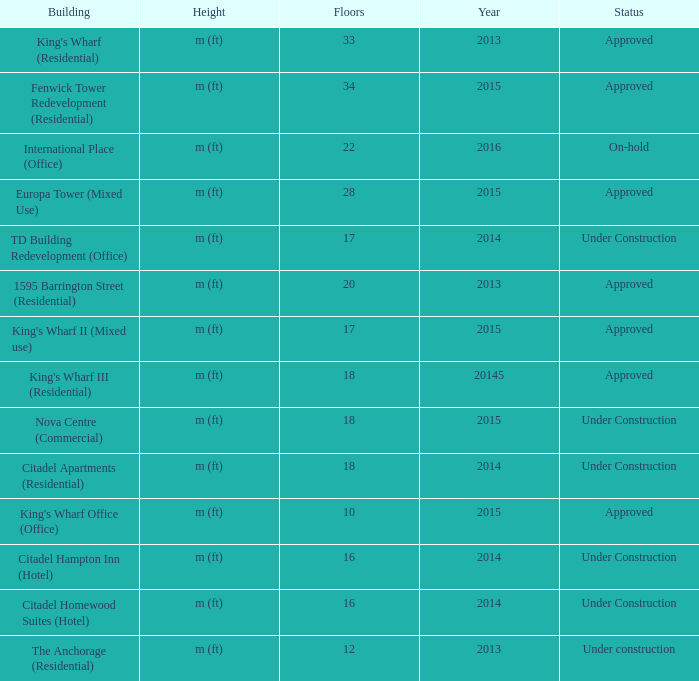How is the building with under 18 floors and built post-2013 faring now? Under Construction, Approved, Approved, Under Construction, Under Construction. 